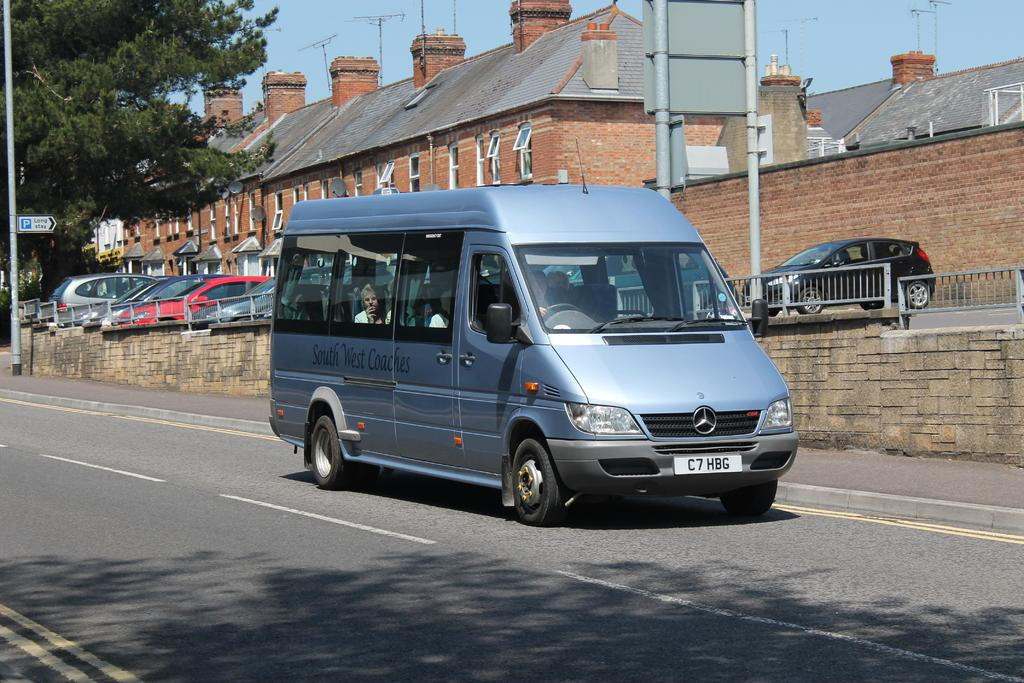<image>
Offer a succinct explanation of the picture presented. a van with c7 on the front of the plate 